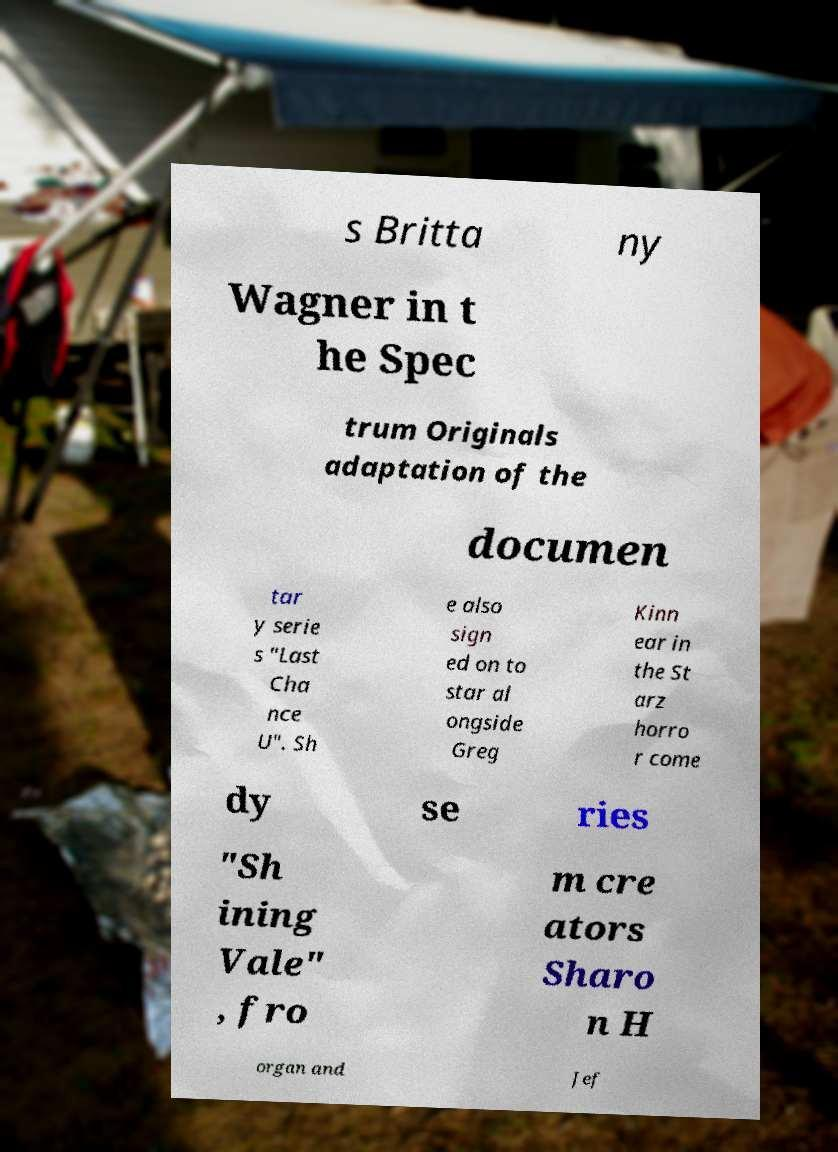There's text embedded in this image that I need extracted. Can you transcribe it verbatim? s Britta ny Wagner in t he Spec trum Originals adaptation of the documen tar y serie s "Last Cha nce U". Sh e also sign ed on to star al ongside Greg Kinn ear in the St arz horro r come dy se ries "Sh ining Vale" , fro m cre ators Sharo n H organ and Jef 